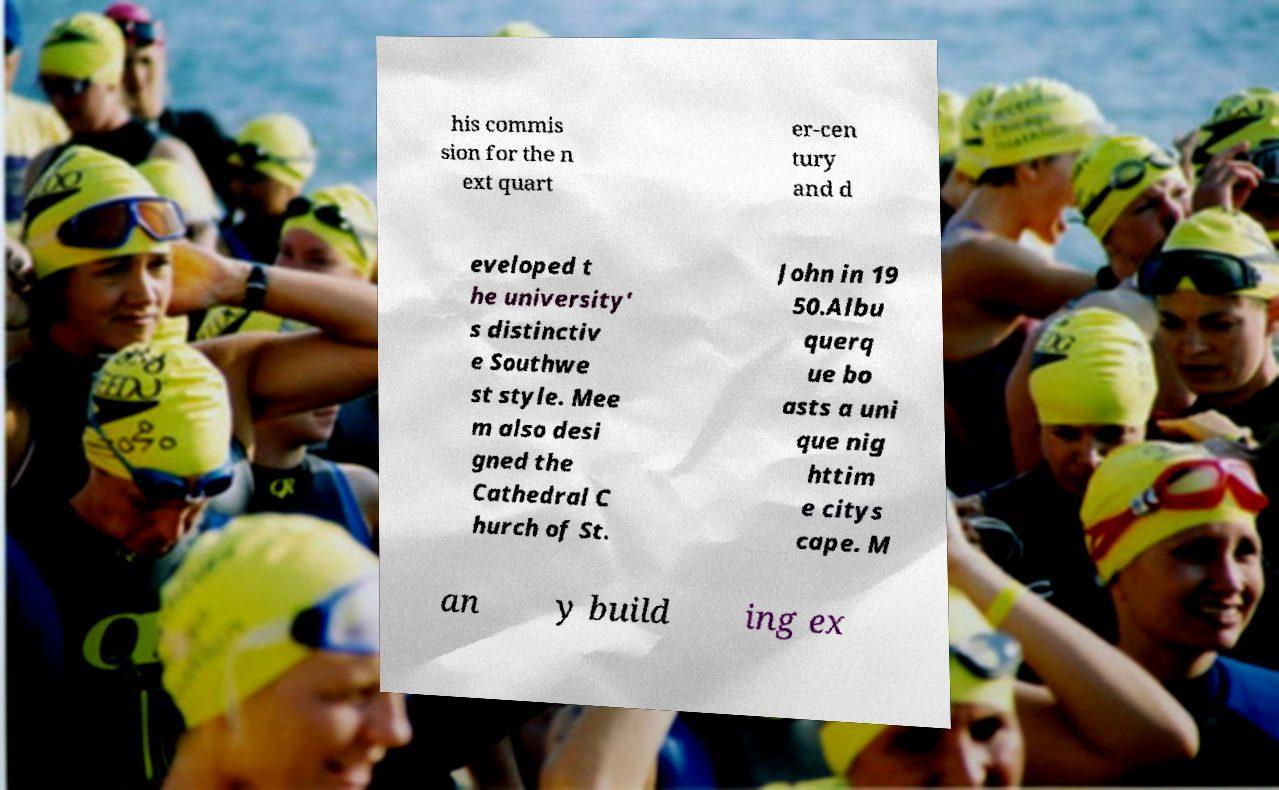There's text embedded in this image that I need extracted. Can you transcribe it verbatim? his commis sion for the n ext quart er-cen tury and d eveloped t he university' s distinctiv e Southwe st style. Mee m also desi gned the Cathedral C hurch of St. John in 19 50.Albu querq ue bo asts a uni que nig httim e citys cape. M an y build ing ex 